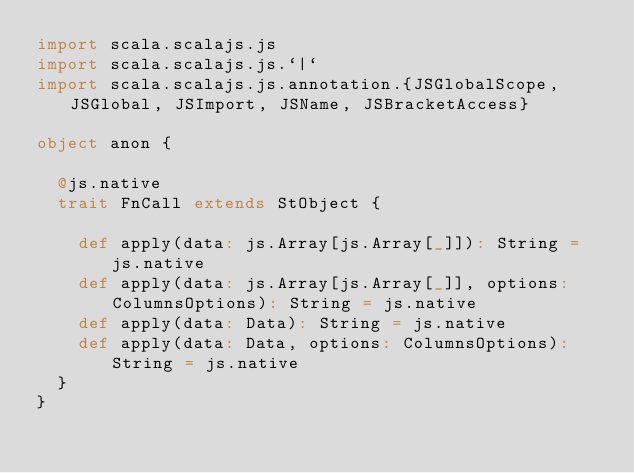Convert code to text. <code><loc_0><loc_0><loc_500><loc_500><_Scala_>import scala.scalajs.js
import scala.scalajs.js.`|`
import scala.scalajs.js.annotation.{JSGlobalScope, JSGlobal, JSImport, JSName, JSBracketAccess}

object anon {
  
  @js.native
  trait FnCall extends StObject {
    
    def apply(data: js.Array[js.Array[_]]): String = js.native
    def apply(data: js.Array[js.Array[_]], options: ColumnsOptions): String = js.native
    def apply(data: Data): String = js.native
    def apply(data: Data, options: ColumnsOptions): String = js.native
  }
}
</code> 